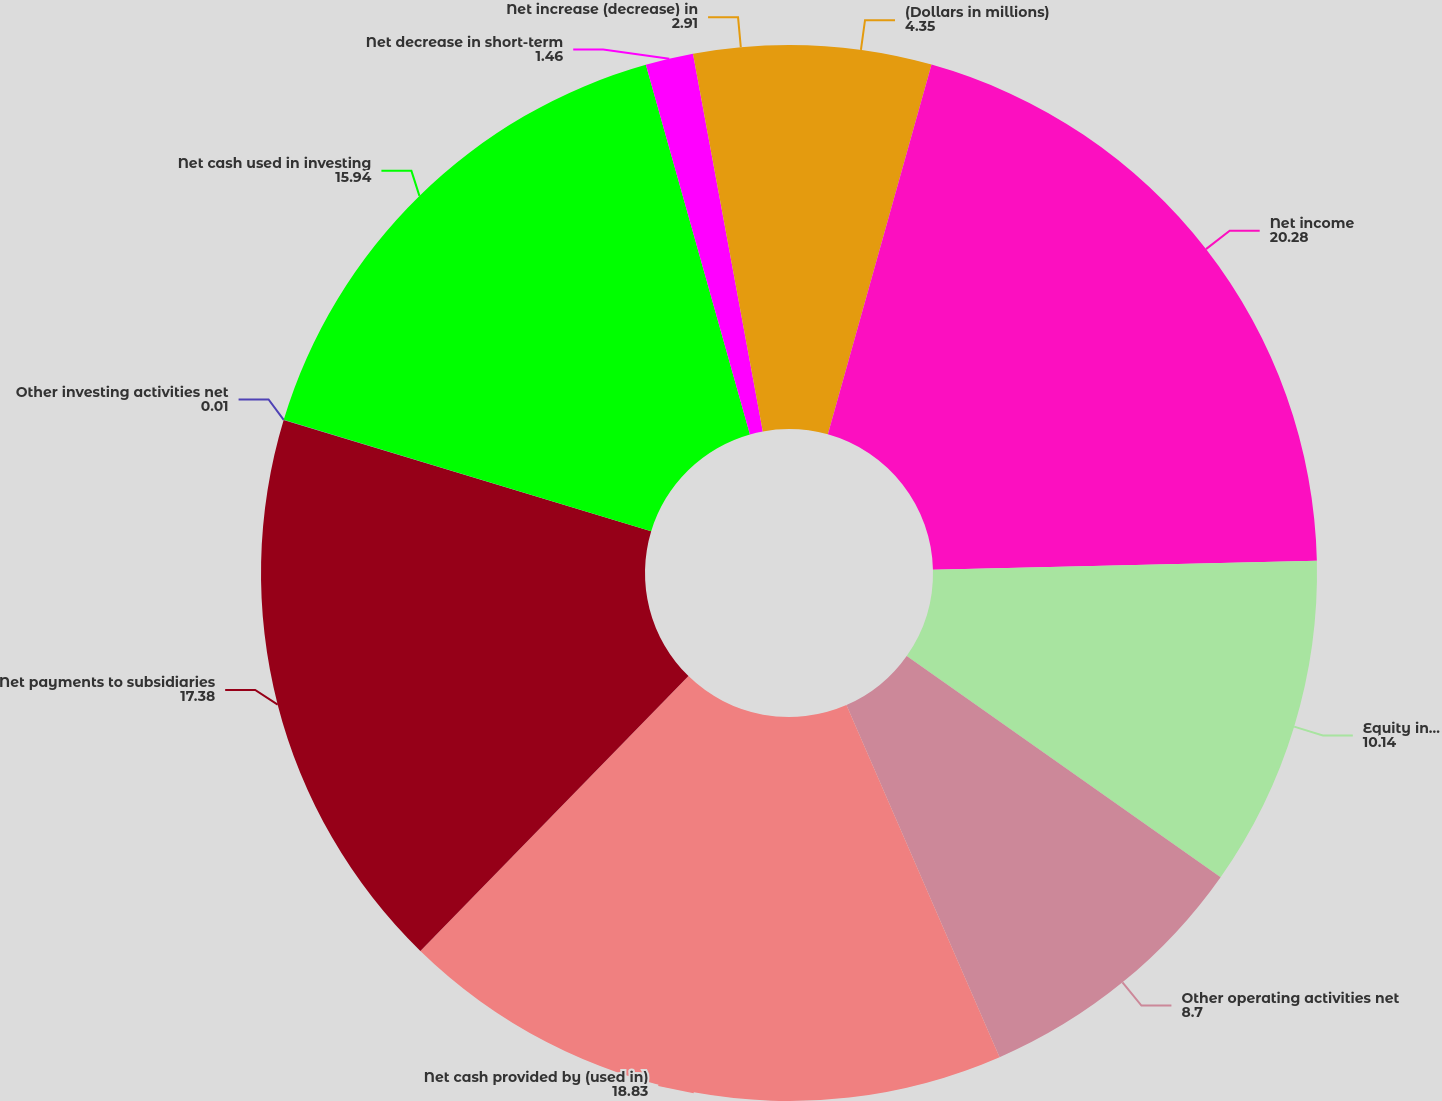<chart> <loc_0><loc_0><loc_500><loc_500><pie_chart><fcel>(Dollars in millions)<fcel>Net income<fcel>Equity in undistributed<fcel>Other operating activities net<fcel>Net cash provided by (used in)<fcel>Net payments to subsidiaries<fcel>Other investing activities net<fcel>Net cash used in investing<fcel>Net decrease in short-term<fcel>Net increase (decrease) in<nl><fcel>4.35%<fcel>20.28%<fcel>10.14%<fcel>8.7%<fcel>18.83%<fcel>17.38%<fcel>0.01%<fcel>15.94%<fcel>1.46%<fcel>2.91%<nl></chart> 